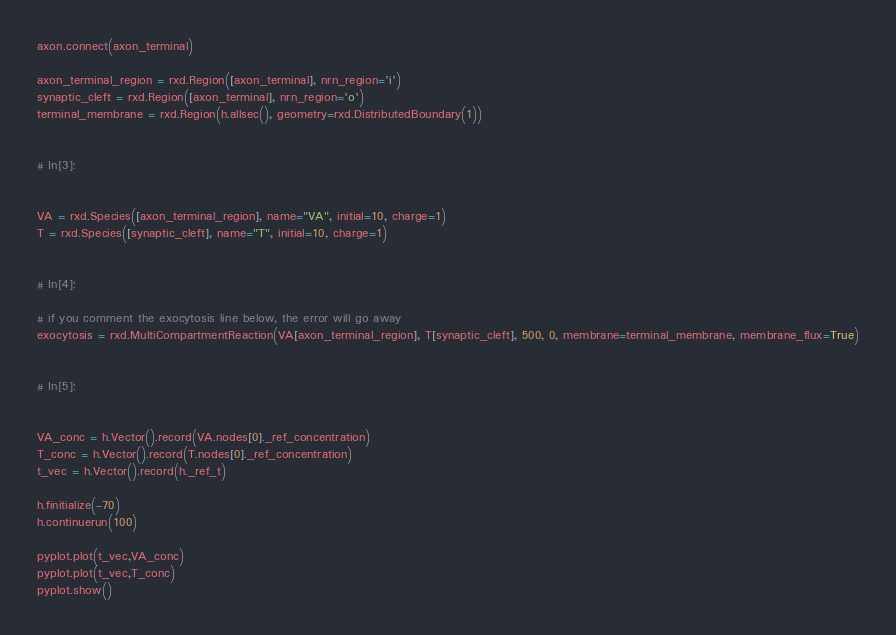<code> <loc_0><loc_0><loc_500><loc_500><_Python_>axon.connect(axon_terminal)

axon_terminal_region = rxd.Region([axon_terminal], nrn_region='i')
synaptic_cleft = rxd.Region([axon_terminal], nrn_region='o')
terminal_membrane = rxd.Region(h.allsec(), geometry=rxd.DistributedBoundary(1))


# In[3]:


VA = rxd.Species([axon_terminal_region], name="VA", initial=10, charge=1)
T = rxd.Species([synaptic_cleft], name="T", initial=10, charge=1)


# In[4]:

# if you comment the exocytosis line below, the error will go away
exocytosis = rxd.MultiCompartmentReaction(VA[axon_terminal_region], T[synaptic_cleft], 500, 0, membrane=terminal_membrane, membrane_flux=True)


# In[5]:


VA_conc = h.Vector().record(VA.nodes[0]._ref_concentration)
T_conc = h.Vector().record(T.nodes[0]._ref_concentration)
t_vec = h.Vector().record(h._ref_t)

h.finitialize(-70)
h.continuerun(100)

pyplot.plot(t_vec,VA_conc)
pyplot.plot(t_vec,T_conc)
pyplot.show()
</code> 